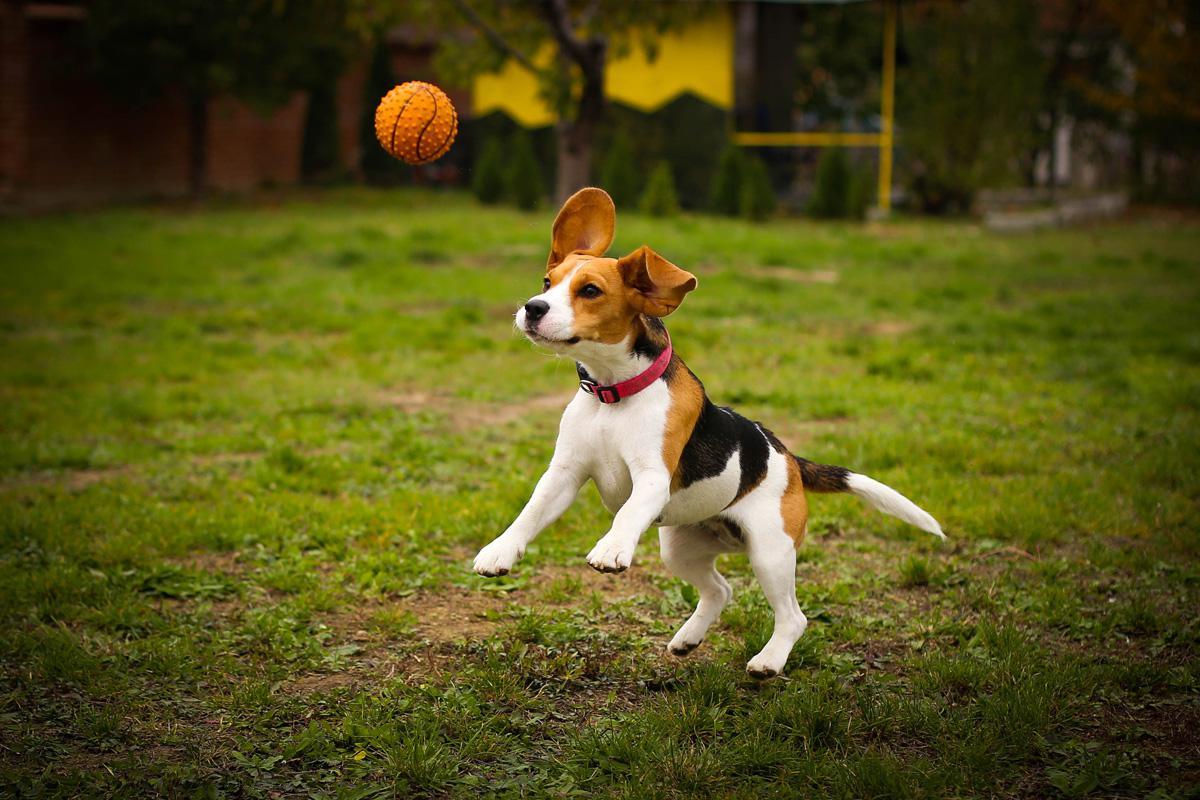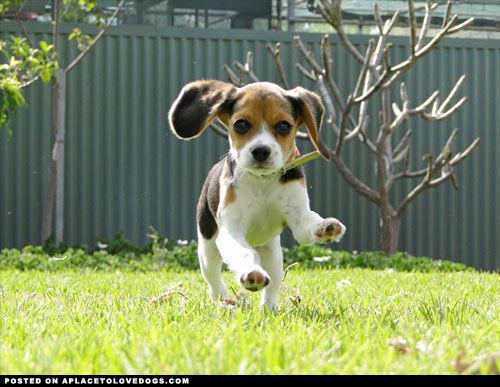The first image is the image on the left, the second image is the image on the right. Assess this claim about the two images: "there is a dog  with a ball in its mouth on a grassy lawn". Correct or not? Answer yes or no. No. The first image is the image on the left, the second image is the image on the right. Considering the images on both sides, is "There are 3 or more puppies playing outside." valid? Answer yes or no. No. 